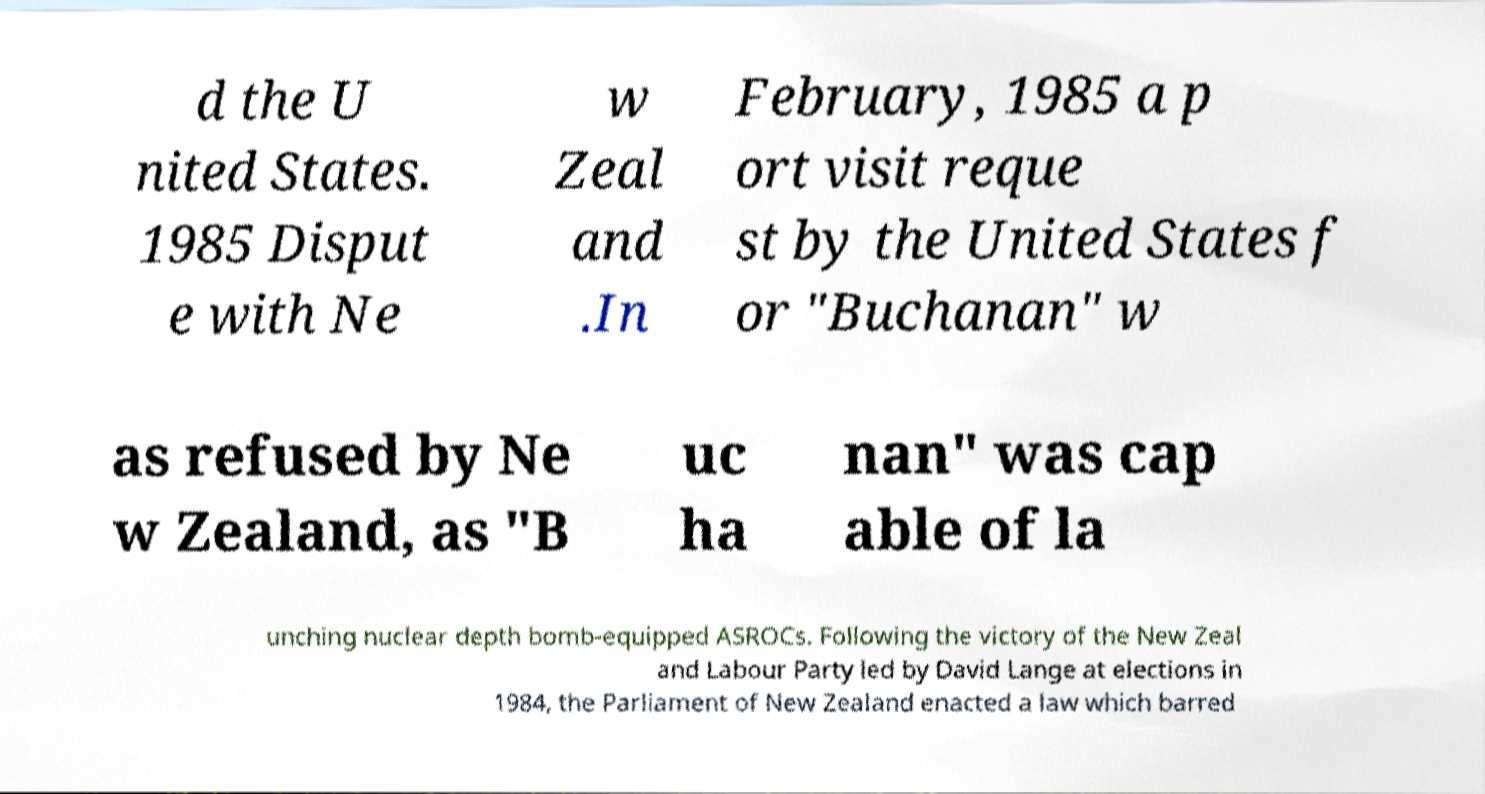Could you assist in decoding the text presented in this image and type it out clearly? d the U nited States. 1985 Disput e with Ne w Zeal and .In February, 1985 a p ort visit reque st by the United States f or "Buchanan" w as refused by Ne w Zealand, as "B uc ha nan" was cap able of la unching nuclear depth bomb-equipped ASROCs. Following the victory of the New Zeal and Labour Party led by David Lange at elections in 1984, the Parliament of New Zealand enacted a law which barred 